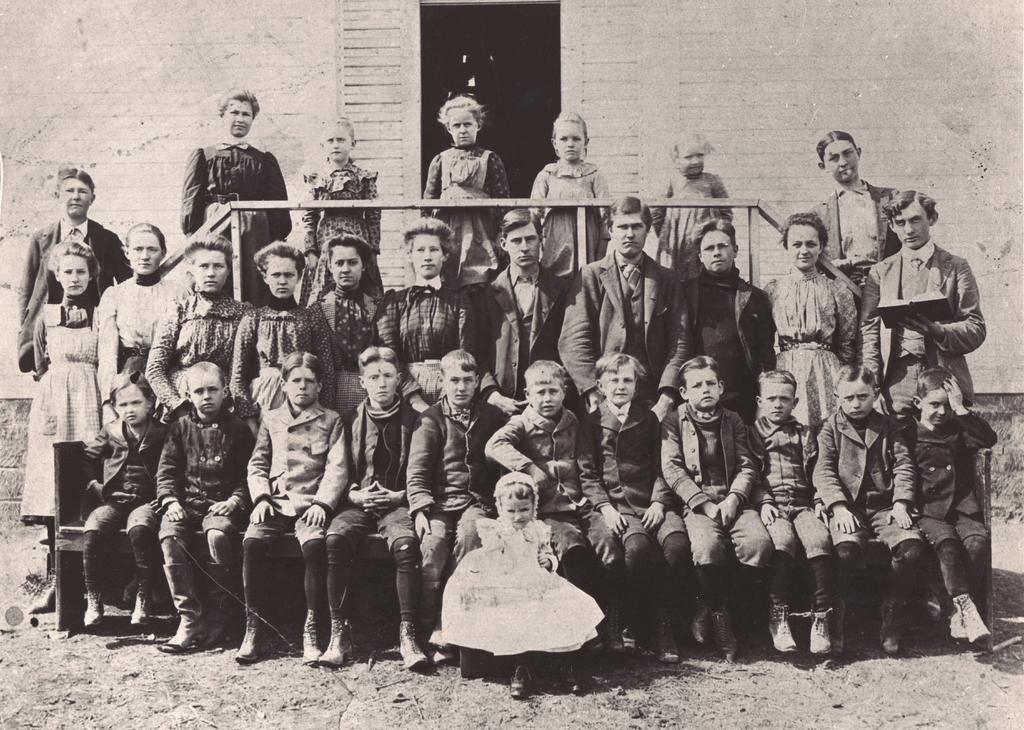In one or two sentences, can you explain what this image depicts? In this picture we can see some people standing and some people sitting, in the background there is a wall, a man on the right side is holding a book, it is a black and white picture. 